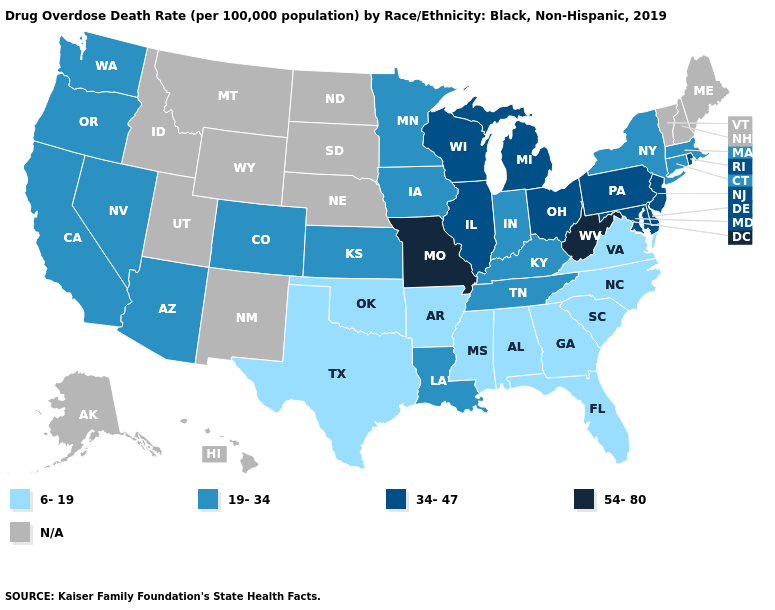Does the map have missing data?
Be succinct. Yes. Is the legend a continuous bar?
Write a very short answer. No. Does the map have missing data?
Answer briefly. Yes. Does North Carolina have the lowest value in the USA?
Quick response, please. Yes. Does the map have missing data?
Short answer required. Yes. What is the highest value in the USA?
Be succinct. 54-80. Does Arkansas have the lowest value in the USA?
Write a very short answer. Yes. Name the states that have a value in the range 34-47?
Quick response, please. Delaware, Illinois, Maryland, Michigan, New Jersey, Ohio, Pennsylvania, Rhode Island, Wisconsin. What is the value of Hawaii?
Concise answer only. N/A. How many symbols are there in the legend?
Concise answer only. 5. Among the states that border New Jersey , which have the lowest value?
Answer briefly. New York. How many symbols are there in the legend?
Be succinct. 5. 